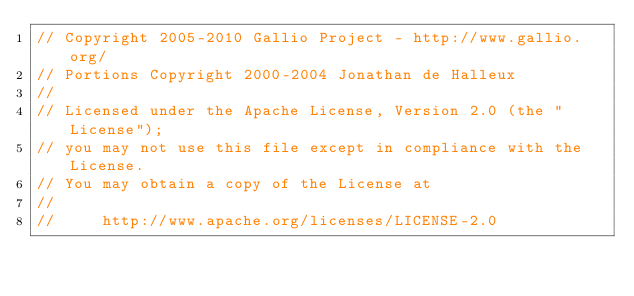Convert code to text. <code><loc_0><loc_0><loc_500><loc_500><_C++_>// Copyright 2005-2010 Gallio Project - http://www.gallio.org/
// Portions Copyright 2000-2004 Jonathan de Halleux
// 
// Licensed under the Apache License, Version 2.0 (the "License");
// you may not use this file except in compliance with the License.
// You may obtain a copy of the License at
// 
//     http://www.apache.org/licenses/LICENSE-2.0</code> 